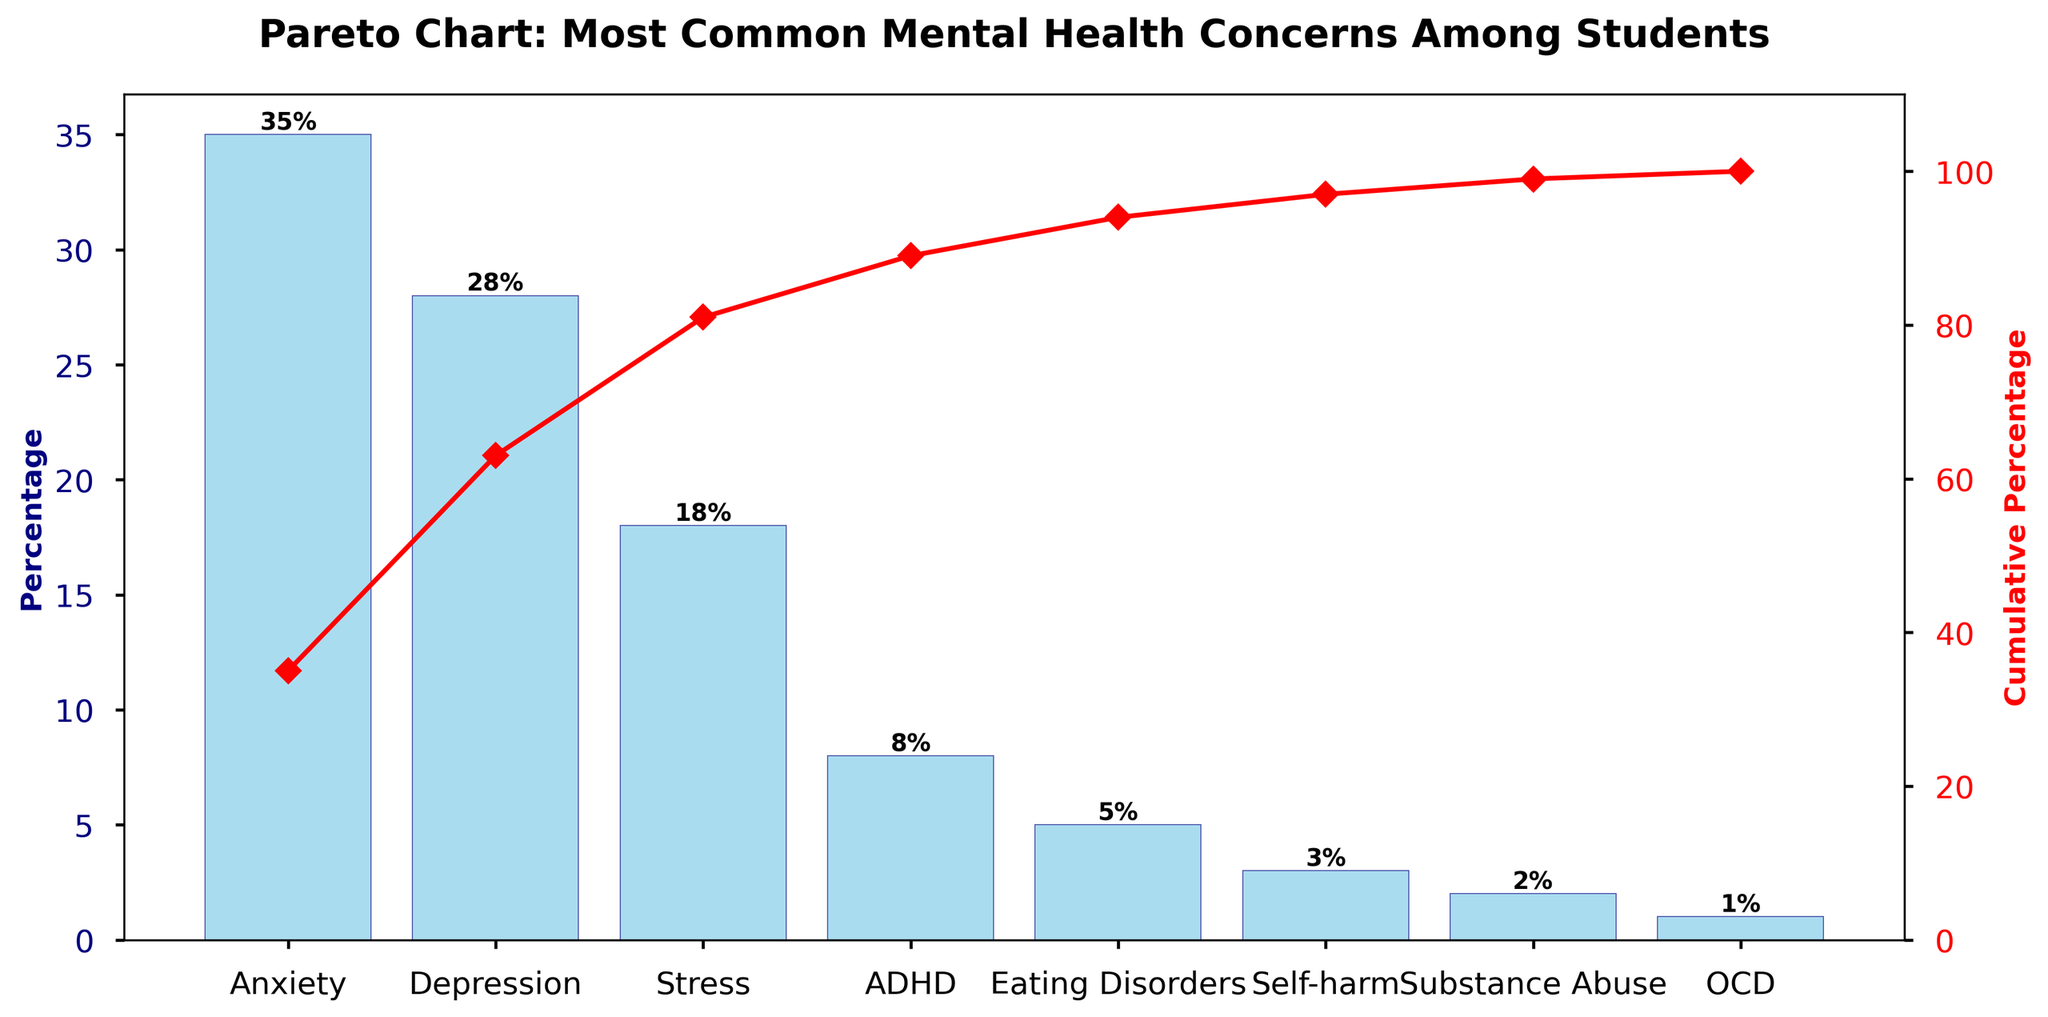What is the most common mental health concern among students? We can see from the bar chart that Anxiety has the highest percentage.
Answer: Anxiety What is the cumulative percentage after Stress is included? By following the cumulative line, we can see that the cumulative percentage reaches 81% after including Stress.
Answer: 81% Which concern has the smallest percentage? By examining the bars, we can see that OCD has the smallest percentage.
Answer: OCD How many mental health concerns have a percentage of 10% or higher? Looking at the bars, Anxiety, Depression, and Stress all have percentages greater than or equal to 10%.
Answer: 3 What color is used for the bars representing the mental health concerns? The bars representing mental health concerns are sky blue with a navy edge color.
Answer: Sky blue What is the percentage difference between Anxiety and Depression? Anxiety has a percentage of 35%, and Depression has 28%. The difference is 35% - 28% = 7%.
Answer: 7% Which mental health concern is directly before Self-harm in the chart? The bar immediately before Self-harm is for Eating Disorders.
Answer: Eating Disorders What cumulative percentage does the secondary y-axis start from? The secondary y-axis for the cumulative percentage starts from 0%.
Answer: 0% Which has a higher percentage, ADHD or Eating Disorders? The bar for ADHD shows 8%, while Eating Disorders show 5%. ADHD has a higher percentage.
Answer: ADHD What is the combined percentage of Anxiety, Depression, and Stress? Adding the percentages of Anxiety (35%), Depression (28%), and Stress (18%) gives us 35% + 28% + 18% = 81%.
Answer: 81% 